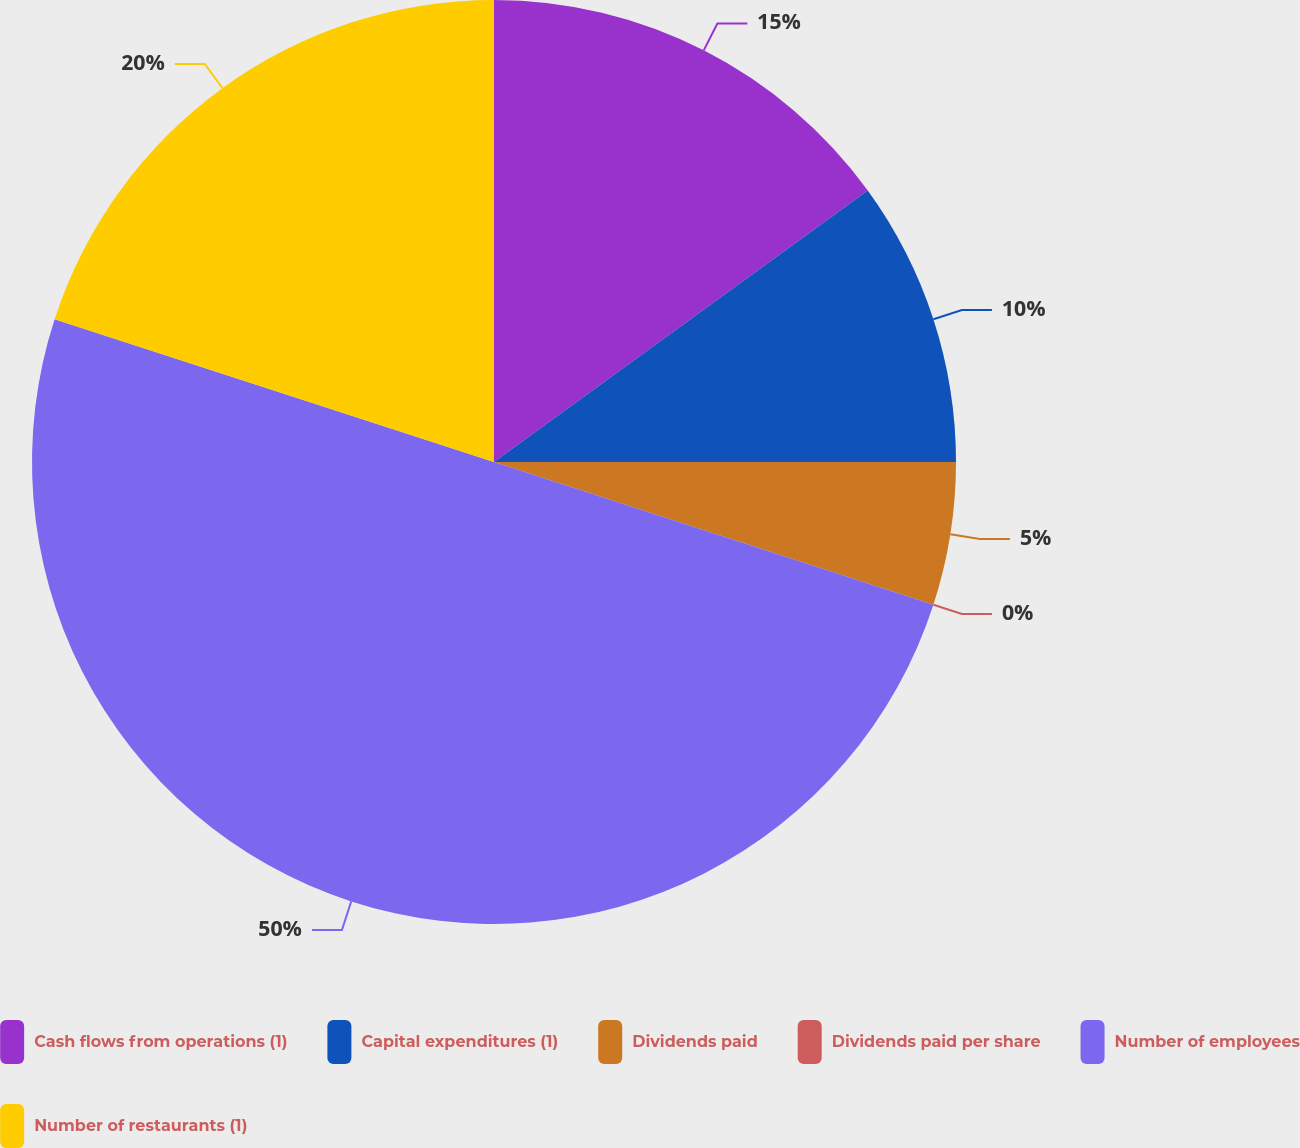<chart> <loc_0><loc_0><loc_500><loc_500><pie_chart><fcel>Cash flows from operations (1)<fcel>Capital expenditures (1)<fcel>Dividends paid<fcel>Dividends paid per share<fcel>Number of employees<fcel>Number of restaurants (1)<nl><fcel>15.0%<fcel>10.0%<fcel>5.0%<fcel>0.0%<fcel>50.0%<fcel>20.0%<nl></chart> 